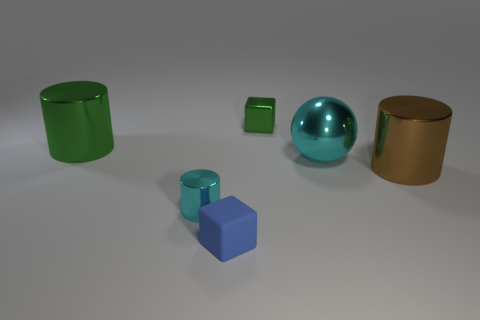What is the material of the small blue block?
Ensure brevity in your answer.  Rubber. What material is the thing behind the green object that is left of the small shiny object on the left side of the tiny rubber cube made of?
Offer a very short reply. Metal. What is the shape of the green object that is the same size as the blue rubber cube?
Keep it short and to the point. Cube. How many objects are either small cyan cylinders or large things on the left side of the large cyan thing?
Offer a very short reply. 2. Do the cyan cylinder on the left side of the shiny ball and the blue thing in front of the tiny shiny cube have the same material?
Provide a succinct answer. No. What shape is the big object that is the same color as the small cylinder?
Provide a short and direct response. Sphere. What number of green things are either metal blocks or rubber balls?
Provide a succinct answer. 1. How big is the brown cylinder?
Your response must be concise. Large. Are there more cyan cylinders that are behind the blue matte cube than small purple cylinders?
Give a very brief answer. Yes. What number of small green blocks are behind the tiny cyan cylinder?
Your response must be concise. 1. 